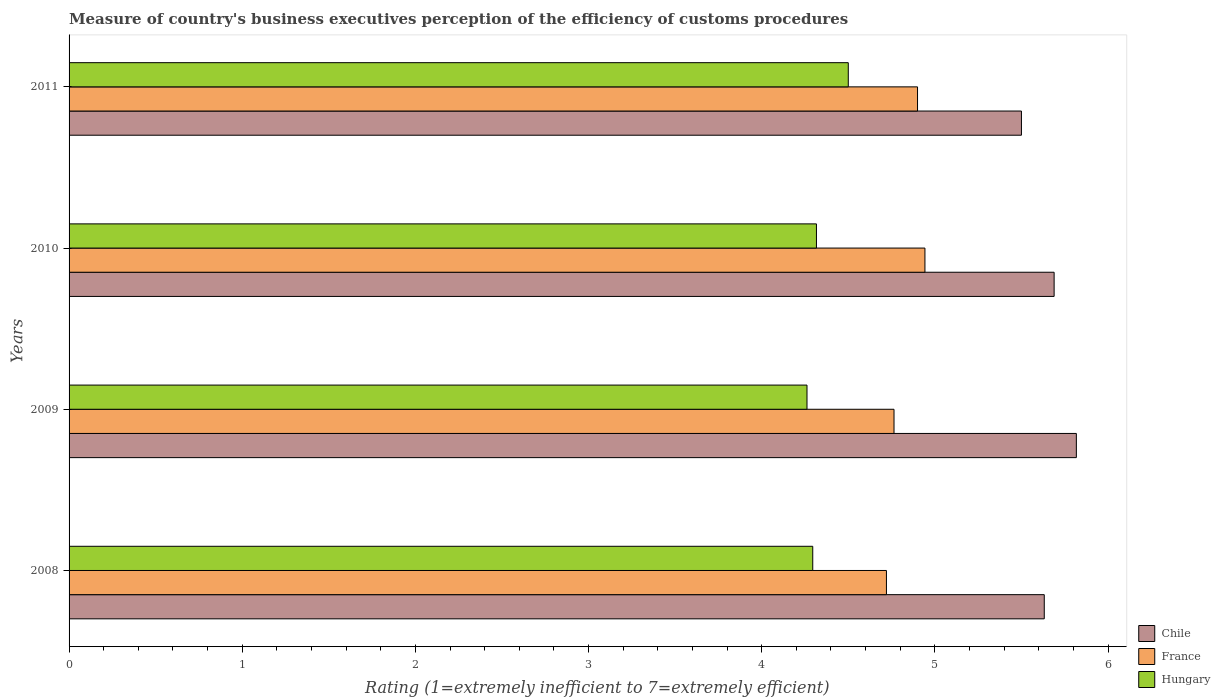How many different coloured bars are there?
Offer a terse response. 3. Are the number of bars on each tick of the Y-axis equal?
Offer a very short reply. Yes. How many bars are there on the 2nd tick from the top?
Your answer should be very brief. 3. What is the label of the 2nd group of bars from the top?
Offer a terse response. 2010. What is the rating of the efficiency of customs procedure in Chile in 2010?
Your response must be concise. 5.69. Across all years, what is the maximum rating of the efficiency of customs procedure in France?
Ensure brevity in your answer.  4.94. Across all years, what is the minimum rating of the efficiency of customs procedure in France?
Offer a terse response. 4.72. In which year was the rating of the efficiency of customs procedure in France maximum?
Give a very brief answer. 2010. In which year was the rating of the efficiency of customs procedure in France minimum?
Provide a short and direct response. 2008. What is the total rating of the efficiency of customs procedure in France in the graph?
Your answer should be compact. 19.33. What is the difference between the rating of the efficiency of customs procedure in France in 2010 and that in 2011?
Make the answer very short. 0.04. What is the difference between the rating of the efficiency of customs procedure in Chile in 2009 and the rating of the efficiency of customs procedure in Hungary in 2011?
Keep it short and to the point. 1.32. What is the average rating of the efficiency of customs procedure in Chile per year?
Provide a short and direct response. 5.66. In the year 2008, what is the difference between the rating of the efficiency of customs procedure in France and rating of the efficiency of customs procedure in Chile?
Ensure brevity in your answer.  -0.91. In how many years, is the rating of the efficiency of customs procedure in Hungary greater than 1.4 ?
Give a very brief answer. 4. What is the ratio of the rating of the efficiency of customs procedure in France in 2010 to that in 2011?
Offer a very short reply. 1.01. Is the difference between the rating of the efficiency of customs procedure in France in 2008 and 2011 greater than the difference between the rating of the efficiency of customs procedure in Chile in 2008 and 2011?
Keep it short and to the point. No. What is the difference between the highest and the second highest rating of the efficiency of customs procedure in France?
Provide a succinct answer. 0.04. What is the difference between the highest and the lowest rating of the efficiency of customs procedure in Chile?
Keep it short and to the point. 0.32. In how many years, is the rating of the efficiency of customs procedure in Hungary greater than the average rating of the efficiency of customs procedure in Hungary taken over all years?
Provide a succinct answer. 1. What does the 3rd bar from the bottom in 2010 represents?
Your response must be concise. Hungary. Are all the bars in the graph horizontal?
Give a very brief answer. Yes. Does the graph contain any zero values?
Your answer should be very brief. No. Where does the legend appear in the graph?
Your answer should be compact. Bottom right. How many legend labels are there?
Offer a terse response. 3. How are the legend labels stacked?
Keep it short and to the point. Vertical. What is the title of the graph?
Offer a very short reply. Measure of country's business executives perception of the efficiency of customs procedures. Does "High income: OECD" appear as one of the legend labels in the graph?
Offer a very short reply. No. What is the label or title of the X-axis?
Keep it short and to the point. Rating (1=extremely inefficient to 7=extremely efficient). What is the Rating (1=extremely inefficient to 7=extremely efficient) in Chile in 2008?
Your answer should be very brief. 5.63. What is the Rating (1=extremely inefficient to 7=extremely efficient) in France in 2008?
Give a very brief answer. 4.72. What is the Rating (1=extremely inefficient to 7=extremely efficient) of Hungary in 2008?
Provide a succinct answer. 4.29. What is the Rating (1=extremely inefficient to 7=extremely efficient) of Chile in 2009?
Provide a succinct answer. 5.82. What is the Rating (1=extremely inefficient to 7=extremely efficient) of France in 2009?
Your response must be concise. 4.76. What is the Rating (1=extremely inefficient to 7=extremely efficient) of Hungary in 2009?
Offer a terse response. 4.26. What is the Rating (1=extremely inefficient to 7=extremely efficient) of Chile in 2010?
Offer a terse response. 5.69. What is the Rating (1=extremely inefficient to 7=extremely efficient) in France in 2010?
Your response must be concise. 4.94. What is the Rating (1=extremely inefficient to 7=extremely efficient) of Hungary in 2010?
Keep it short and to the point. 4.32. What is the Rating (1=extremely inefficient to 7=extremely efficient) in Chile in 2011?
Your response must be concise. 5.5. What is the Rating (1=extremely inefficient to 7=extremely efficient) of France in 2011?
Offer a very short reply. 4.9. What is the Rating (1=extremely inefficient to 7=extremely efficient) in Hungary in 2011?
Keep it short and to the point. 4.5. Across all years, what is the maximum Rating (1=extremely inefficient to 7=extremely efficient) in Chile?
Make the answer very short. 5.82. Across all years, what is the maximum Rating (1=extremely inefficient to 7=extremely efficient) of France?
Your answer should be compact. 4.94. Across all years, what is the maximum Rating (1=extremely inefficient to 7=extremely efficient) in Hungary?
Provide a short and direct response. 4.5. Across all years, what is the minimum Rating (1=extremely inefficient to 7=extremely efficient) of France?
Keep it short and to the point. 4.72. Across all years, what is the minimum Rating (1=extremely inefficient to 7=extremely efficient) of Hungary?
Offer a terse response. 4.26. What is the total Rating (1=extremely inefficient to 7=extremely efficient) of Chile in the graph?
Offer a terse response. 22.64. What is the total Rating (1=extremely inefficient to 7=extremely efficient) in France in the graph?
Ensure brevity in your answer.  19.33. What is the total Rating (1=extremely inefficient to 7=extremely efficient) in Hungary in the graph?
Give a very brief answer. 17.37. What is the difference between the Rating (1=extremely inefficient to 7=extremely efficient) of Chile in 2008 and that in 2009?
Provide a succinct answer. -0.19. What is the difference between the Rating (1=extremely inefficient to 7=extremely efficient) of France in 2008 and that in 2009?
Keep it short and to the point. -0.04. What is the difference between the Rating (1=extremely inefficient to 7=extremely efficient) of Hungary in 2008 and that in 2009?
Your answer should be compact. 0.03. What is the difference between the Rating (1=extremely inefficient to 7=extremely efficient) in Chile in 2008 and that in 2010?
Ensure brevity in your answer.  -0.06. What is the difference between the Rating (1=extremely inefficient to 7=extremely efficient) in France in 2008 and that in 2010?
Offer a terse response. -0.22. What is the difference between the Rating (1=extremely inefficient to 7=extremely efficient) in Hungary in 2008 and that in 2010?
Provide a short and direct response. -0.02. What is the difference between the Rating (1=extremely inefficient to 7=extremely efficient) in Chile in 2008 and that in 2011?
Keep it short and to the point. 0.13. What is the difference between the Rating (1=extremely inefficient to 7=extremely efficient) of France in 2008 and that in 2011?
Give a very brief answer. -0.18. What is the difference between the Rating (1=extremely inefficient to 7=extremely efficient) of Hungary in 2008 and that in 2011?
Offer a very short reply. -0.21. What is the difference between the Rating (1=extremely inefficient to 7=extremely efficient) in Chile in 2009 and that in 2010?
Your answer should be compact. 0.13. What is the difference between the Rating (1=extremely inefficient to 7=extremely efficient) of France in 2009 and that in 2010?
Your answer should be compact. -0.18. What is the difference between the Rating (1=extremely inefficient to 7=extremely efficient) of Hungary in 2009 and that in 2010?
Ensure brevity in your answer.  -0.05. What is the difference between the Rating (1=extremely inefficient to 7=extremely efficient) of Chile in 2009 and that in 2011?
Your answer should be compact. 0.32. What is the difference between the Rating (1=extremely inefficient to 7=extremely efficient) in France in 2009 and that in 2011?
Make the answer very short. -0.14. What is the difference between the Rating (1=extremely inefficient to 7=extremely efficient) in Hungary in 2009 and that in 2011?
Ensure brevity in your answer.  -0.24. What is the difference between the Rating (1=extremely inefficient to 7=extremely efficient) in Chile in 2010 and that in 2011?
Give a very brief answer. 0.19. What is the difference between the Rating (1=extremely inefficient to 7=extremely efficient) of France in 2010 and that in 2011?
Offer a very short reply. 0.04. What is the difference between the Rating (1=extremely inefficient to 7=extremely efficient) in Hungary in 2010 and that in 2011?
Your answer should be compact. -0.18. What is the difference between the Rating (1=extremely inefficient to 7=extremely efficient) of Chile in 2008 and the Rating (1=extremely inefficient to 7=extremely efficient) of France in 2009?
Offer a terse response. 0.87. What is the difference between the Rating (1=extremely inefficient to 7=extremely efficient) in Chile in 2008 and the Rating (1=extremely inefficient to 7=extremely efficient) in Hungary in 2009?
Your answer should be compact. 1.37. What is the difference between the Rating (1=extremely inefficient to 7=extremely efficient) of France in 2008 and the Rating (1=extremely inefficient to 7=extremely efficient) of Hungary in 2009?
Provide a short and direct response. 0.46. What is the difference between the Rating (1=extremely inefficient to 7=extremely efficient) in Chile in 2008 and the Rating (1=extremely inefficient to 7=extremely efficient) in France in 2010?
Offer a terse response. 0.69. What is the difference between the Rating (1=extremely inefficient to 7=extremely efficient) of Chile in 2008 and the Rating (1=extremely inefficient to 7=extremely efficient) of Hungary in 2010?
Your response must be concise. 1.32. What is the difference between the Rating (1=extremely inefficient to 7=extremely efficient) of France in 2008 and the Rating (1=extremely inefficient to 7=extremely efficient) of Hungary in 2010?
Your response must be concise. 0.4. What is the difference between the Rating (1=extremely inefficient to 7=extremely efficient) of Chile in 2008 and the Rating (1=extremely inefficient to 7=extremely efficient) of France in 2011?
Make the answer very short. 0.73. What is the difference between the Rating (1=extremely inefficient to 7=extremely efficient) in Chile in 2008 and the Rating (1=extremely inefficient to 7=extremely efficient) in Hungary in 2011?
Give a very brief answer. 1.13. What is the difference between the Rating (1=extremely inefficient to 7=extremely efficient) of France in 2008 and the Rating (1=extremely inefficient to 7=extremely efficient) of Hungary in 2011?
Keep it short and to the point. 0.22. What is the difference between the Rating (1=extremely inefficient to 7=extremely efficient) of Chile in 2009 and the Rating (1=extremely inefficient to 7=extremely efficient) of France in 2010?
Your response must be concise. 0.87. What is the difference between the Rating (1=extremely inefficient to 7=extremely efficient) of Chile in 2009 and the Rating (1=extremely inefficient to 7=extremely efficient) of Hungary in 2010?
Your answer should be very brief. 1.5. What is the difference between the Rating (1=extremely inefficient to 7=extremely efficient) of France in 2009 and the Rating (1=extremely inefficient to 7=extremely efficient) of Hungary in 2010?
Ensure brevity in your answer.  0.45. What is the difference between the Rating (1=extremely inefficient to 7=extremely efficient) of Chile in 2009 and the Rating (1=extremely inefficient to 7=extremely efficient) of France in 2011?
Provide a short and direct response. 0.92. What is the difference between the Rating (1=extremely inefficient to 7=extremely efficient) in Chile in 2009 and the Rating (1=extremely inefficient to 7=extremely efficient) in Hungary in 2011?
Keep it short and to the point. 1.32. What is the difference between the Rating (1=extremely inefficient to 7=extremely efficient) of France in 2009 and the Rating (1=extremely inefficient to 7=extremely efficient) of Hungary in 2011?
Provide a short and direct response. 0.26. What is the difference between the Rating (1=extremely inefficient to 7=extremely efficient) of Chile in 2010 and the Rating (1=extremely inefficient to 7=extremely efficient) of France in 2011?
Your response must be concise. 0.79. What is the difference between the Rating (1=extremely inefficient to 7=extremely efficient) of Chile in 2010 and the Rating (1=extremely inefficient to 7=extremely efficient) of Hungary in 2011?
Your response must be concise. 1.19. What is the difference between the Rating (1=extremely inefficient to 7=extremely efficient) of France in 2010 and the Rating (1=extremely inefficient to 7=extremely efficient) of Hungary in 2011?
Keep it short and to the point. 0.44. What is the average Rating (1=extremely inefficient to 7=extremely efficient) of Chile per year?
Keep it short and to the point. 5.66. What is the average Rating (1=extremely inefficient to 7=extremely efficient) in France per year?
Provide a succinct answer. 4.83. What is the average Rating (1=extremely inefficient to 7=extremely efficient) of Hungary per year?
Give a very brief answer. 4.34. In the year 2008, what is the difference between the Rating (1=extremely inefficient to 7=extremely efficient) in Chile and Rating (1=extremely inefficient to 7=extremely efficient) in France?
Your answer should be compact. 0.91. In the year 2008, what is the difference between the Rating (1=extremely inefficient to 7=extremely efficient) of Chile and Rating (1=extremely inefficient to 7=extremely efficient) of Hungary?
Your response must be concise. 1.34. In the year 2008, what is the difference between the Rating (1=extremely inefficient to 7=extremely efficient) in France and Rating (1=extremely inefficient to 7=extremely efficient) in Hungary?
Offer a very short reply. 0.43. In the year 2009, what is the difference between the Rating (1=extremely inefficient to 7=extremely efficient) of Chile and Rating (1=extremely inefficient to 7=extremely efficient) of France?
Your answer should be very brief. 1.05. In the year 2009, what is the difference between the Rating (1=extremely inefficient to 7=extremely efficient) of Chile and Rating (1=extremely inefficient to 7=extremely efficient) of Hungary?
Ensure brevity in your answer.  1.56. In the year 2009, what is the difference between the Rating (1=extremely inefficient to 7=extremely efficient) in France and Rating (1=extremely inefficient to 7=extremely efficient) in Hungary?
Your response must be concise. 0.5. In the year 2010, what is the difference between the Rating (1=extremely inefficient to 7=extremely efficient) in Chile and Rating (1=extremely inefficient to 7=extremely efficient) in France?
Offer a very short reply. 0.75. In the year 2010, what is the difference between the Rating (1=extremely inefficient to 7=extremely efficient) of Chile and Rating (1=extremely inefficient to 7=extremely efficient) of Hungary?
Your response must be concise. 1.37. In the year 2010, what is the difference between the Rating (1=extremely inefficient to 7=extremely efficient) in France and Rating (1=extremely inefficient to 7=extremely efficient) in Hungary?
Ensure brevity in your answer.  0.63. In the year 2011, what is the difference between the Rating (1=extremely inefficient to 7=extremely efficient) of Chile and Rating (1=extremely inefficient to 7=extremely efficient) of Hungary?
Keep it short and to the point. 1. What is the ratio of the Rating (1=extremely inefficient to 7=extremely efficient) of Chile in 2008 to that in 2009?
Provide a succinct answer. 0.97. What is the ratio of the Rating (1=extremely inefficient to 7=extremely efficient) in Hungary in 2008 to that in 2009?
Keep it short and to the point. 1.01. What is the ratio of the Rating (1=extremely inefficient to 7=extremely efficient) of Chile in 2008 to that in 2010?
Your response must be concise. 0.99. What is the ratio of the Rating (1=extremely inefficient to 7=extremely efficient) in France in 2008 to that in 2010?
Offer a very short reply. 0.95. What is the ratio of the Rating (1=extremely inefficient to 7=extremely efficient) in Hungary in 2008 to that in 2010?
Your answer should be very brief. 1. What is the ratio of the Rating (1=extremely inefficient to 7=extremely efficient) in France in 2008 to that in 2011?
Your answer should be very brief. 0.96. What is the ratio of the Rating (1=extremely inefficient to 7=extremely efficient) in Hungary in 2008 to that in 2011?
Your response must be concise. 0.95. What is the ratio of the Rating (1=extremely inefficient to 7=extremely efficient) of Chile in 2009 to that in 2010?
Provide a succinct answer. 1.02. What is the ratio of the Rating (1=extremely inefficient to 7=extremely efficient) in France in 2009 to that in 2010?
Offer a very short reply. 0.96. What is the ratio of the Rating (1=extremely inefficient to 7=extremely efficient) in Hungary in 2009 to that in 2010?
Your answer should be compact. 0.99. What is the ratio of the Rating (1=extremely inefficient to 7=extremely efficient) in Chile in 2009 to that in 2011?
Make the answer very short. 1.06. What is the ratio of the Rating (1=extremely inefficient to 7=extremely efficient) in France in 2009 to that in 2011?
Offer a terse response. 0.97. What is the ratio of the Rating (1=extremely inefficient to 7=extremely efficient) in Hungary in 2009 to that in 2011?
Give a very brief answer. 0.95. What is the ratio of the Rating (1=extremely inefficient to 7=extremely efficient) in Chile in 2010 to that in 2011?
Provide a succinct answer. 1.03. What is the ratio of the Rating (1=extremely inefficient to 7=extremely efficient) in France in 2010 to that in 2011?
Your answer should be very brief. 1.01. What is the ratio of the Rating (1=extremely inefficient to 7=extremely efficient) in Hungary in 2010 to that in 2011?
Give a very brief answer. 0.96. What is the difference between the highest and the second highest Rating (1=extremely inefficient to 7=extremely efficient) of Chile?
Ensure brevity in your answer.  0.13. What is the difference between the highest and the second highest Rating (1=extremely inefficient to 7=extremely efficient) of France?
Ensure brevity in your answer.  0.04. What is the difference between the highest and the second highest Rating (1=extremely inefficient to 7=extremely efficient) in Hungary?
Provide a short and direct response. 0.18. What is the difference between the highest and the lowest Rating (1=extremely inefficient to 7=extremely efficient) in Chile?
Ensure brevity in your answer.  0.32. What is the difference between the highest and the lowest Rating (1=extremely inefficient to 7=extremely efficient) in France?
Ensure brevity in your answer.  0.22. What is the difference between the highest and the lowest Rating (1=extremely inefficient to 7=extremely efficient) of Hungary?
Ensure brevity in your answer.  0.24. 